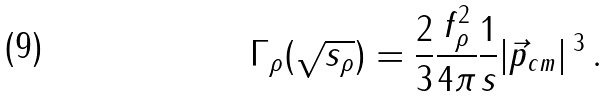Convert formula to latex. <formula><loc_0><loc_0><loc_500><loc_500>\Gamma _ { \rho } ( \sqrt { s _ { \rho } } ) = \frac { 2 } { 3 } \frac { f _ { \rho } ^ { 2 } } { 4 \pi } \frac { 1 } { s } | \vec { p } _ { c m } | \, ^ { 3 } \, .</formula> 